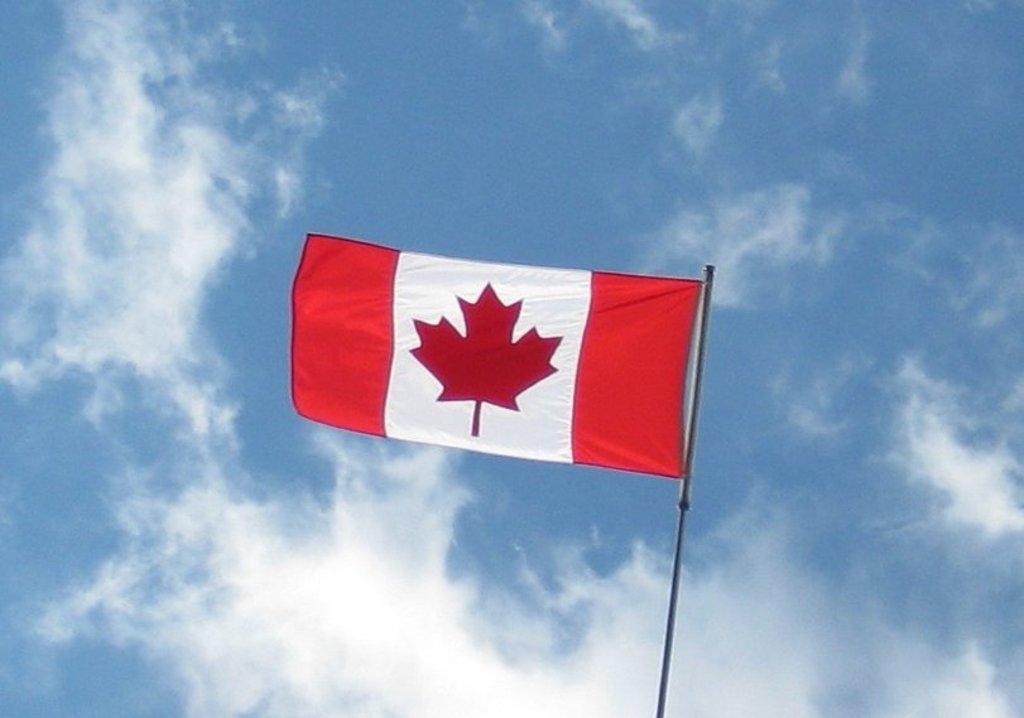What is the main subject in the center of the image? There is a flag in the center of the image. What can be seen in the background of the image? Sky is visible in the background of the image. What is the condition of the sky in the image? Clouds are present in the sky. What type of yam is being used to stop the impulse in the image? There is no yam or impulse present in the image. 